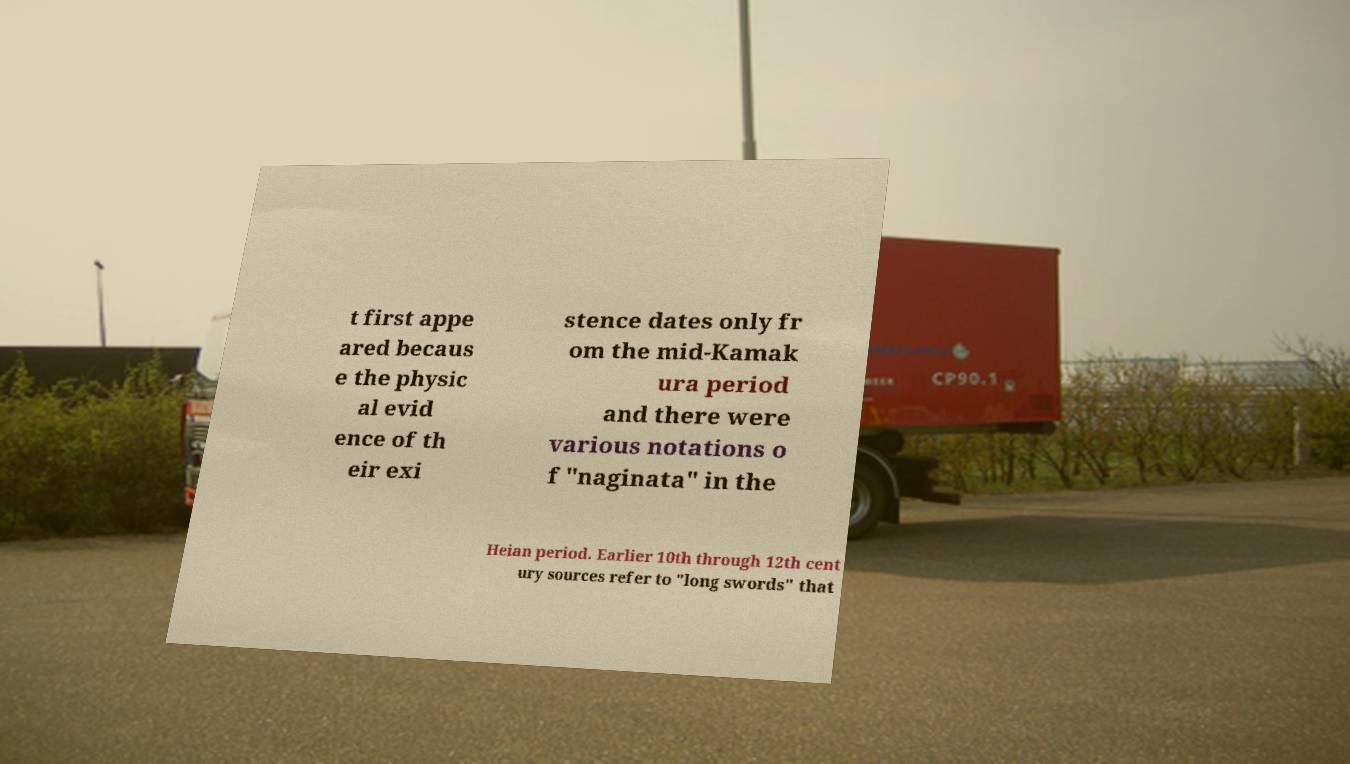I need the written content from this picture converted into text. Can you do that? t first appe ared becaus e the physic al evid ence of th eir exi stence dates only fr om the mid-Kamak ura period and there were various notations o f "naginata" in the Heian period. Earlier 10th through 12th cent ury sources refer to "long swords" that 